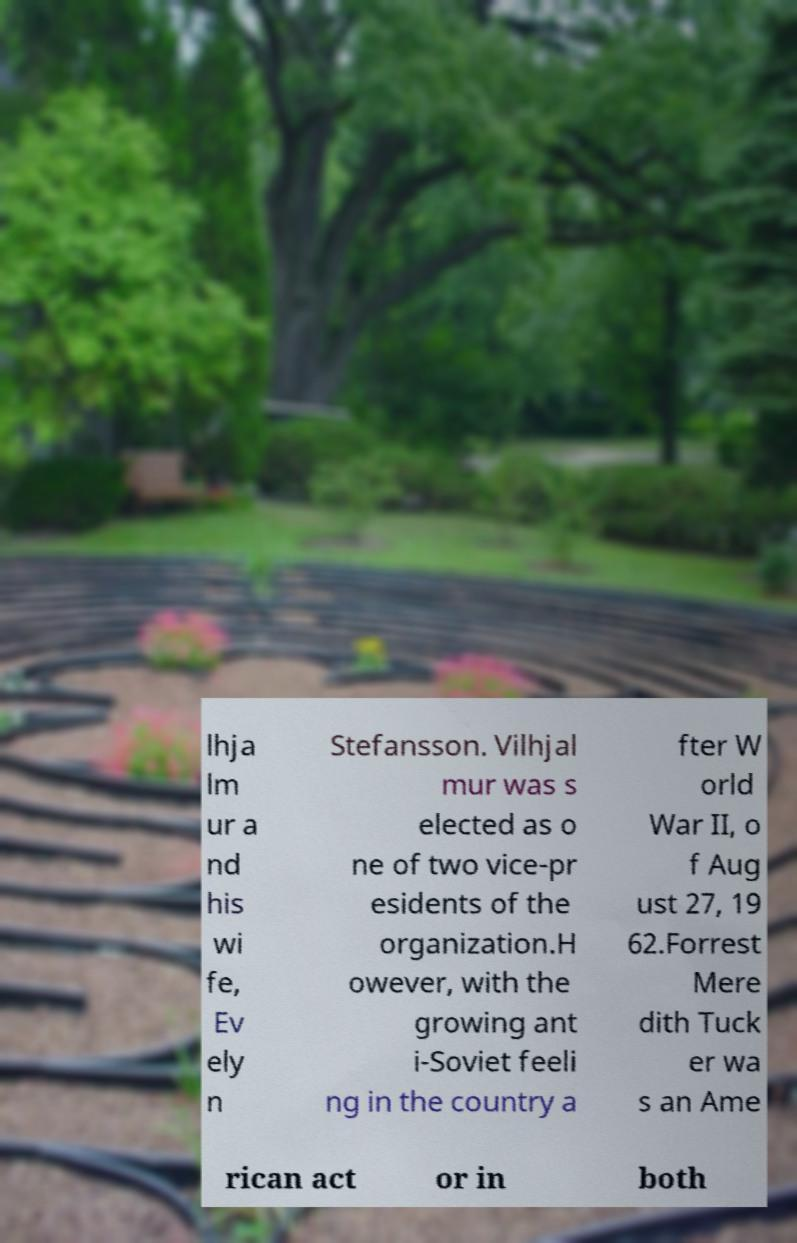Can you accurately transcribe the text from the provided image for me? lhja lm ur a nd his wi fe, Ev ely n Stefansson. Vilhjal mur was s elected as o ne of two vice-pr esidents of the organization.H owever, with the growing ant i-Soviet feeli ng in the country a fter W orld War II, o f Aug ust 27, 19 62.Forrest Mere dith Tuck er wa s an Ame rican act or in both 